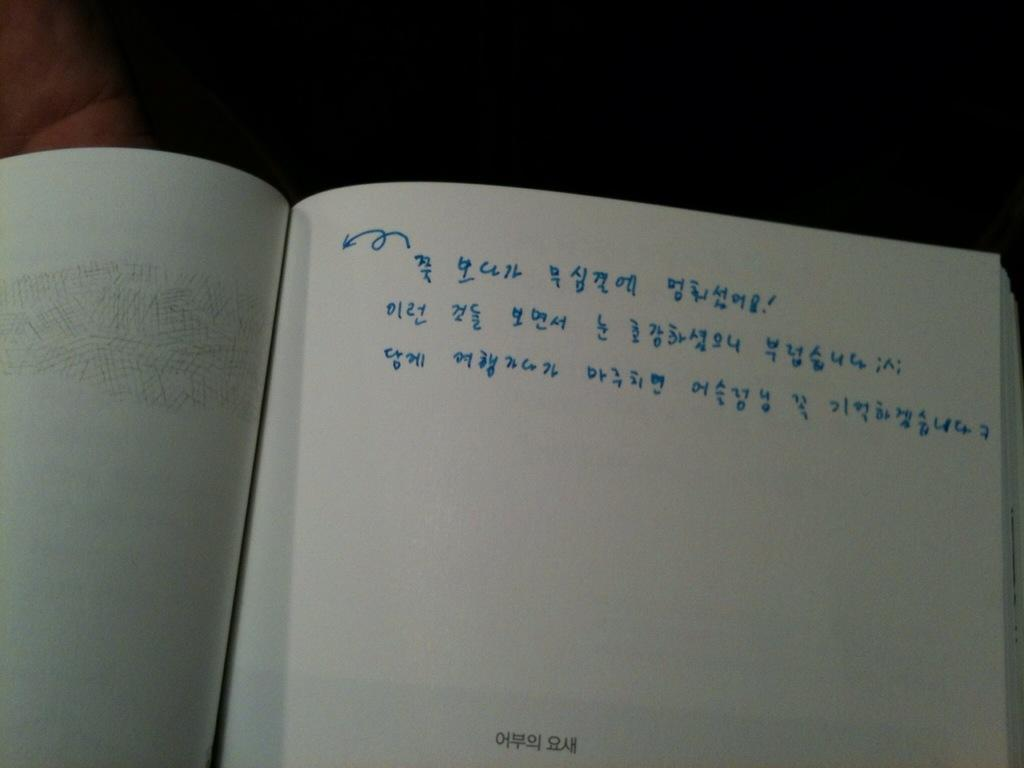Provide a one-sentence caption for the provided image. A small bit of Asian writing is the only other writing on a page half filled with blue numbers. 